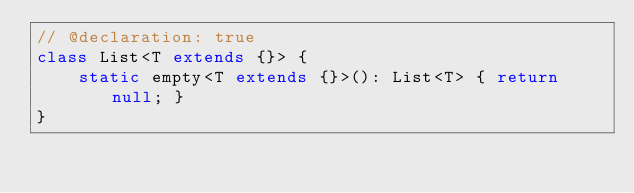<code> <loc_0><loc_0><loc_500><loc_500><_TypeScript_>// @declaration: true
class List<T extends {}> {
    static empty<T extends {}>(): List<T> { return null; }
}
</code> 